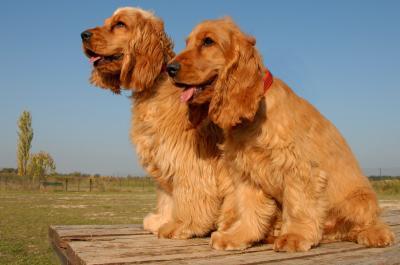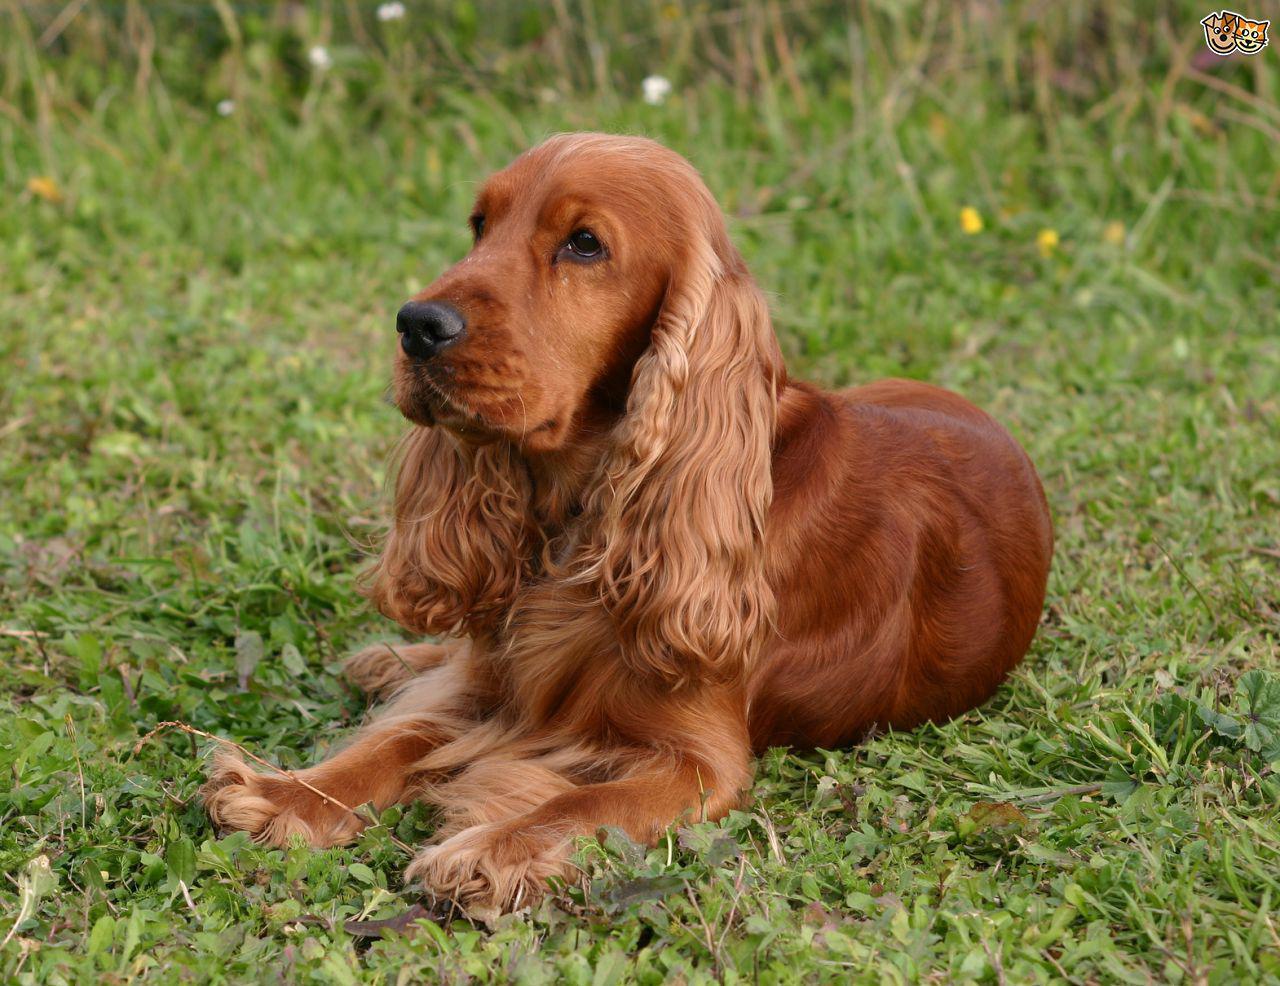The first image is the image on the left, the second image is the image on the right. Examine the images to the left and right. Is the description "The right image shows a young puppy." accurate? Answer yes or no. No. 